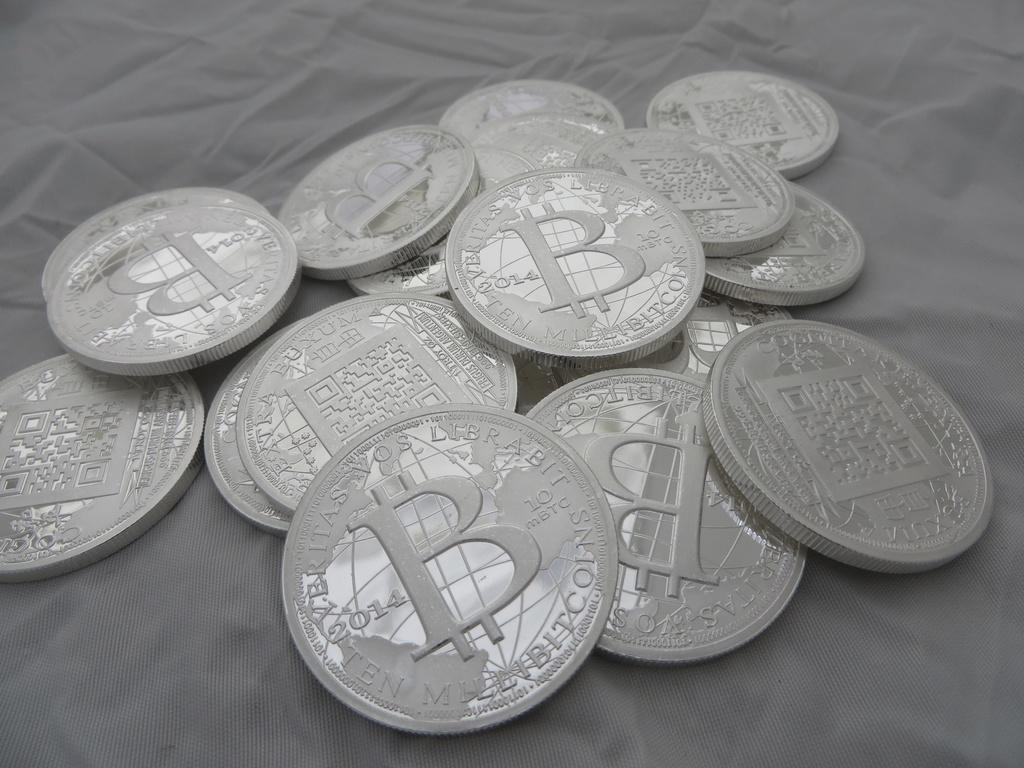Provide a one-sentence caption for the provided image. Several bitcoin tokens are shown with a large B in the center and the words "Veritas Vos Librabit" on the top edge. 